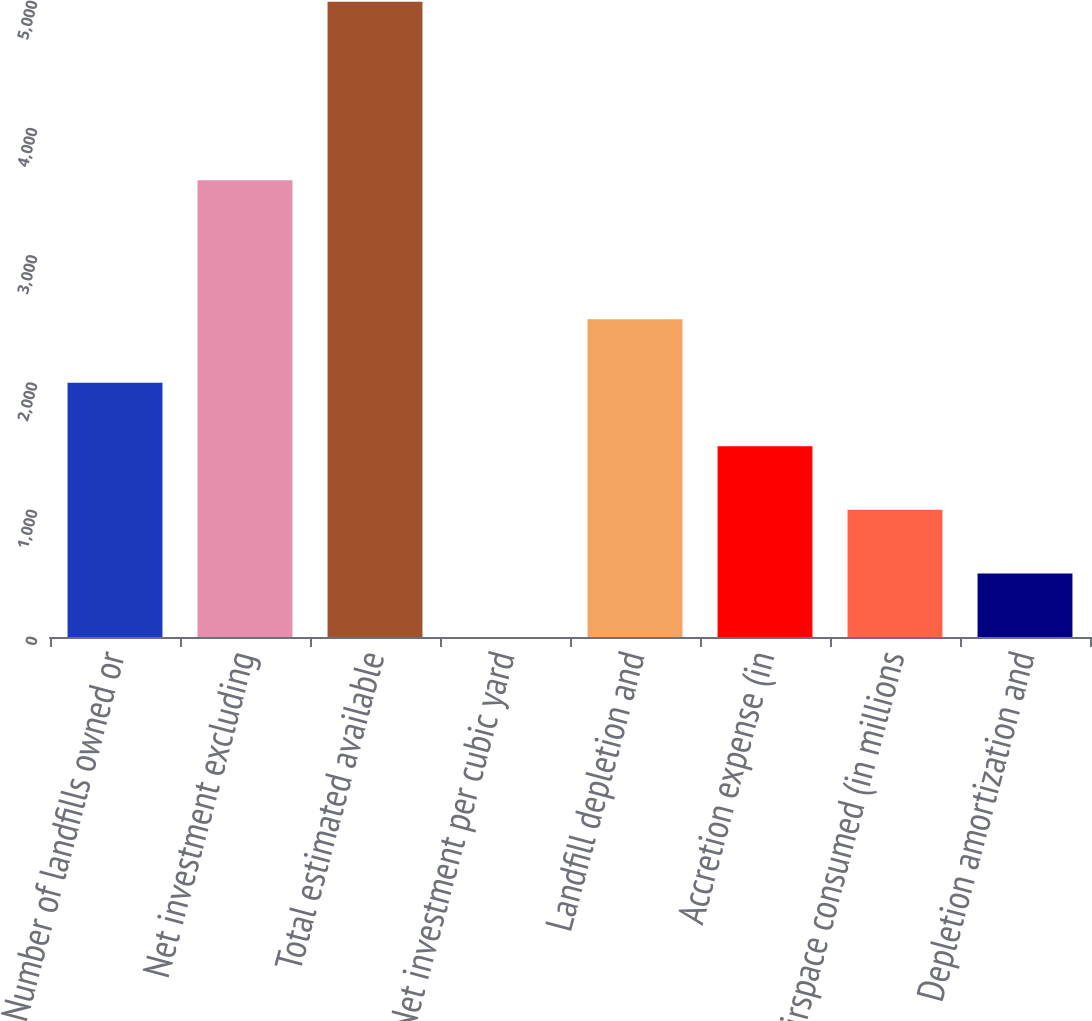Convert chart. <chart><loc_0><loc_0><loc_500><loc_500><bar_chart><fcel>Number of landfills owned or<fcel>Net investment excluding<fcel>Total estimated available<fcel>Net investment per cubic yard<fcel>Landfill depletion and<fcel>Accretion expense (in<fcel>Airspace consumed (in millions<fcel>Depletion amortization and<nl><fcel>1998.2<fcel>3591.4<fcel>4994.4<fcel>0.72<fcel>2497.57<fcel>1498.83<fcel>999.46<fcel>500.09<nl></chart> 